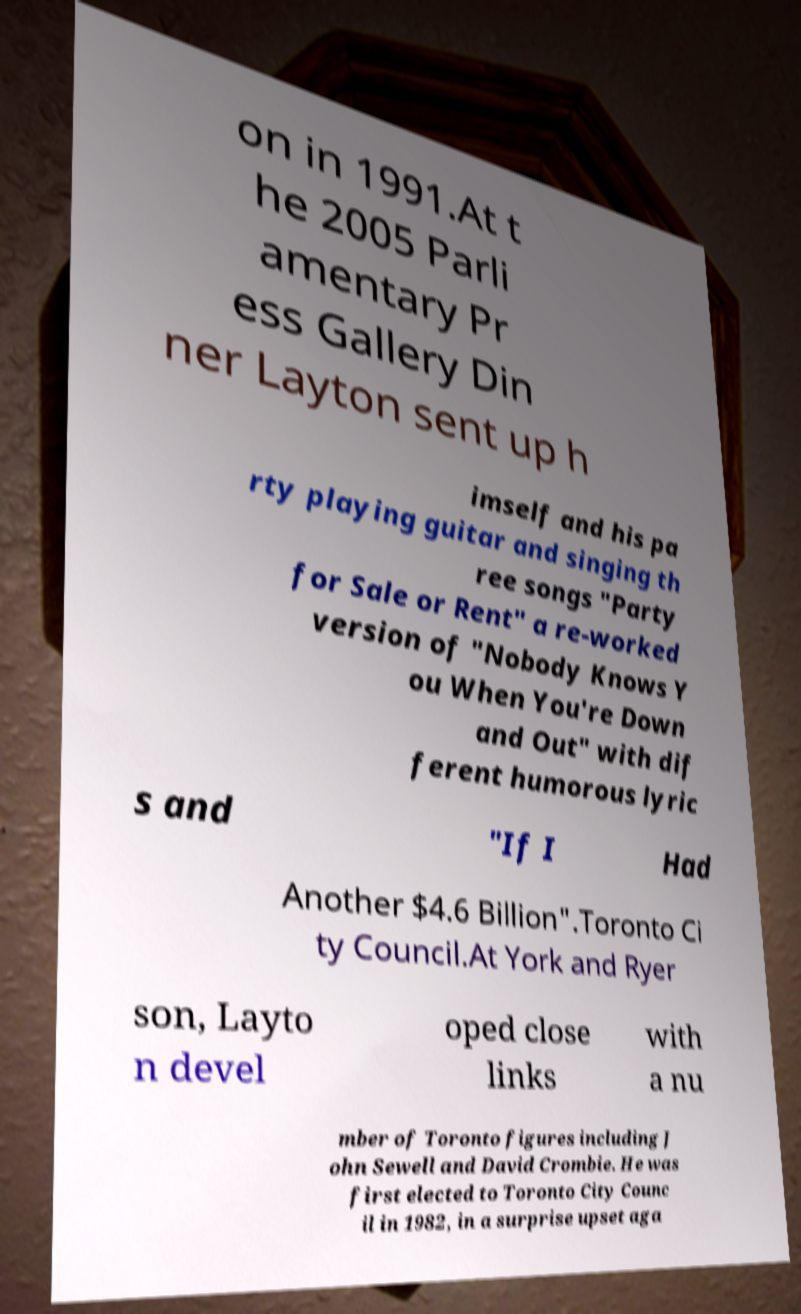Please identify and transcribe the text found in this image. on in 1991.At t he 2005 Parli amentary Pr ess Gallery Din ner Layton sent up h imself and his pa rty playing guitar and singing th ree songs "Party for Sale or Rent" a re-worked version of "Nobody Knows Y ou When You're Down and Out" with dif ferent humorous lyric s and "If I Had Another $4.6 Billion".Toronto Ci ty Council.At York and Ryer son, Layto n devel oped close links with a nu mber of Toronto figures including J ohn Sewell and David Crombie. He was first elected to Toronto City Counc il in 1982, in a surprise upset aga 